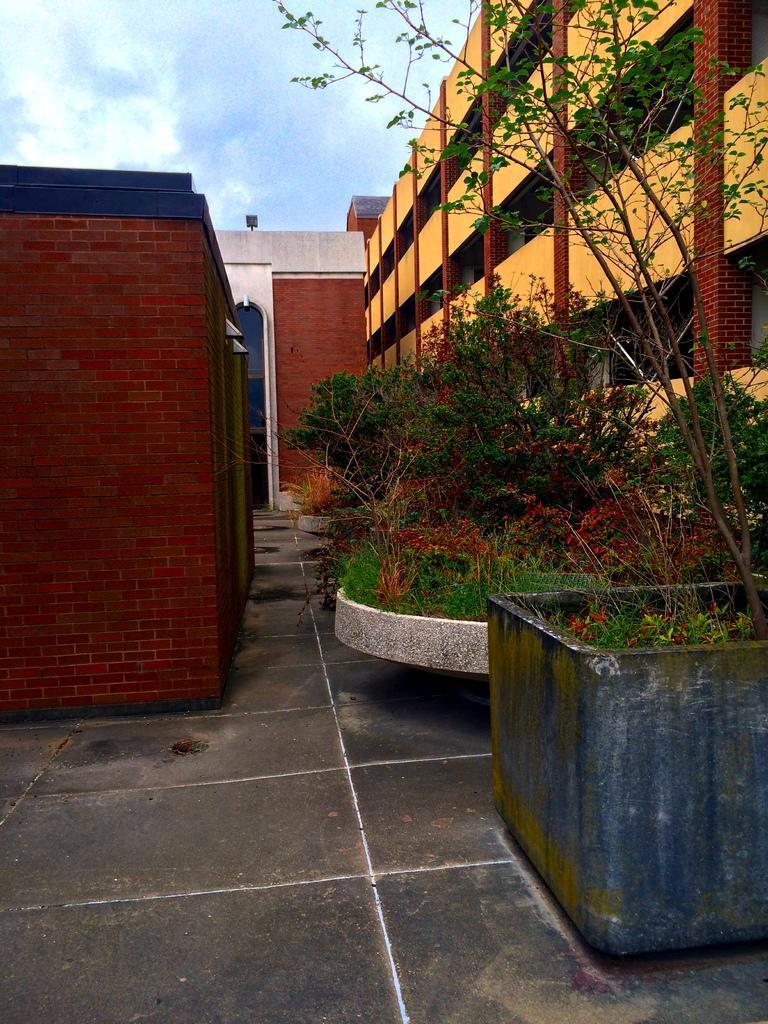How would you summarize this image in a sentence or two? In the image I can see a building and also I can see some plants and some other things around. 